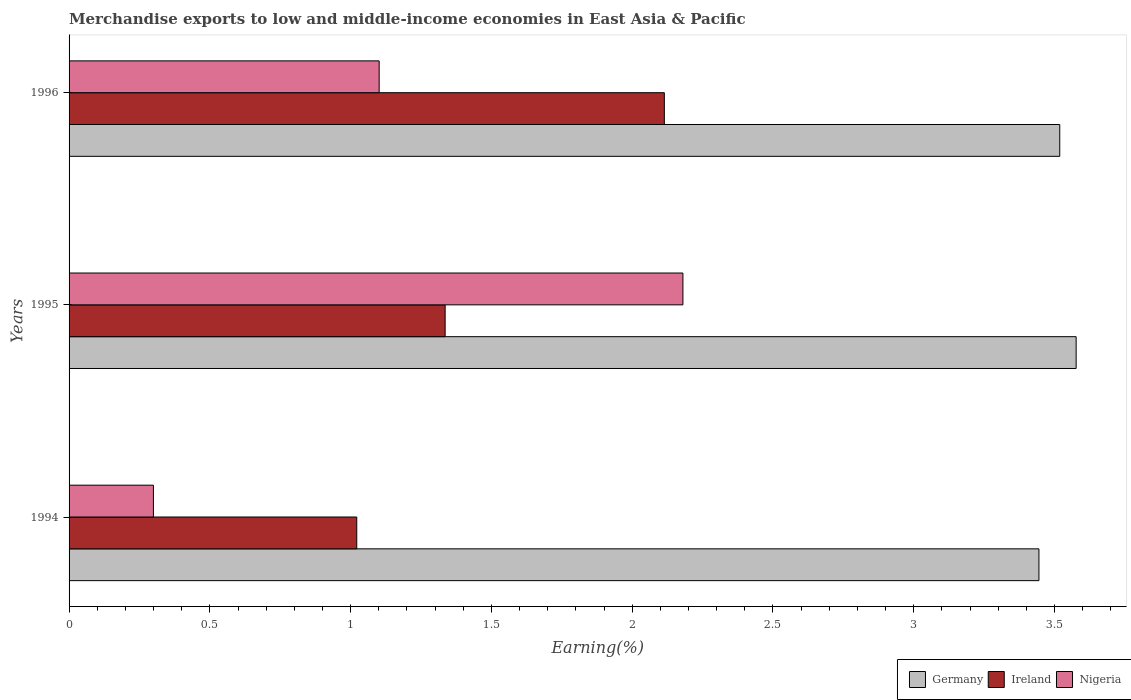Are the number of bars per tick equal to the number of legend labels?
Ensure brevity in your answer.  Yes. How many bars are there on the 1st tick from the top?
Offer a very short reply. 3. How many bars are there on the 3rd tick from the bottom?
Offer a very short reply. 3. What is the label of the 3rd group of bars from the top?
Provide a succinct answer. 1994. In how many cases, is the number of bars for a given year not equal to the number of legend labels?
Your response must be concise. 0. What is the percentage of amount earned from merchandise exports in Germany in 1996?
Your response must be concise. 3.52. Across all years, what is the maximum percentage of amount earned from merchandise exports in Nigeria?
Your answer should be compact. 2.18. Across all years, what is the minimum percentage of amount earned from merchandise exports in Ireland?
Your answer should be very brief. 1.02. What is the total percentage of amount earned from merchandise exports in Germany in the graph?
Make the answer very short. 10.54. What is the difference between the percentage of amount earned from merchandise exports in Nigeria in 1994 and that in 1995?
Provide a succinct answer. -1.88. What is the difference between the percentage of amount earned from merchandise exports in Ireland in 1994 and the percentage of amount earned from merchandise exports in Germany in 1995?
Provide a short and direct response. -2.56. What is the average percentage of amount earned from merchandise exports in Ireland per year?
Keep it short and to the point. 1.49. In the year 1994, what is the difference between the percentage of amount earned from merchandise exports in Germany and percentage of amount earned from merchandise exports in Nigeria?
Your response must be concise. 3.15. In how many years, is the percentage of amount earned from merchandise exports in Nigeria greater than 1.5 %?
Give a very brief answer. 1. What is the ratio of the percentage of amount earned from merchandise exports in Nigeria in 1995 to that in 1996?
Make the answer very short. 1.98. Is the percentage of amount earned from merchandise exports in Nigeria in 1994 less than that in 1996?
Offer a terse response. Yes. What is the difference between the highest and the second highest percentage of amount earned from merchandise exports in Nigeria?
Your answer should be compact. 1.08. What is the difference between the highest and the lowest percentage of amount earned from merchandise exports in Germany?
Your response must be concise. 0.13. In how many years, is the percentage of amount earned from merchandise exports in Ireland greater than the average percentage of amount earned from merchandise exports in Ireland taken over all years?
Your answer should be compact. 1. Is the sum of the percentage of amount earned from merchandise exports in Ireland in 1995 and 1996 greater than the maximum percentage of amount earned from merchandise exports in Germany across all years?
Provide a short and direct response. No. What does the 2nd bar from the top in 1994 represents?
Provide a succinct answer. Ireland. What does the 3rd bar from the bottom in 1995 represents?
Your answer should be compact. Nigeria. How many years are there in the graph?
Make the answer very short. 3. What is the difference between two consecutive major ticks on the X-axis?
Give a very brief answer. 0.5. Does the graph contain grids?
Your answer should be very brief. No. How many legend labels are there?
Keep it short and to the point. 3. What is the title of the graph?
Provide a short and direct response. Merchandise exports to low and middle-income economies in East Asia & Pacific. What is the label or title of the X-axis?
Give a very brief answer. Earning(%). What is the Earning(%) of Germany in 1994?
Offer a terse response. 3.44. What is the Earning(%) of Ireland in 1994?
Give a very brief answer. 1.02. What is the Earning(%) of Nigeria in 1994?
Ensure brevity in your answer.  0.3. What is the Earning(%) of Germany in 1995?
Provide a short and direct response. 3.58. What is the Earning(%) in Ireland in 1995?
Your response must be concise. 1.34. What is the Earning(%) of Nigeria in 1995?
Make the answer very short. 2.18. What is the Earning(%) in Germany in 1996?
Your answer should be very brief. 3.52. What is the Earning(%) of Ireland in 1996?
Ensure brevity in your answer.  2.11. What is the Earning(%) in Nigeria in 1996?
Your answer should be very brief. 1.1. Across all years, what is the maximum Earning(%) of Germany?
Ensure brevity in your answer.  3.58. Across all years, what is the maximum Earning(%) in Ireland?
Offer a very short reply. 2.11. Across all years, what is the maximum Earning(%) in Nigeria?
Your answer should be very brief. 2.18. Across all years, what is the minimum Earning(%) of Germany?
Make the answer very short. 3.44. Across all years, what is the minimum Earning(%) of Ireland?
Provide a succinct answer. 1.02. Across all years, what is the minimum Earning(%) of Nigeria?
Your answer should be compact. 0.3. What is the total Earning(%) in Germany in the graph?
Make the answer very short. 10.54. What is the total Earning(%) of Ireland in the graph?
Make the answer very short. 4.47. What is the total Earning(%) of Nigeria in the graph?
Ensure brevity in your answer.  3.58. What is the difference between the Earning(%) of Germany in 1994 and that in 1995?
Make the answer very short. -0.13. What is the difference between the Earning(%) of Ireland in 1994 and that in 1995?
Provide a succinct answer. -0.31. What is the difference between the Earning(%) of Nigeria in 1994 and that in 1995?
Your response must be concise. -1.88. What is the difference between the Earning(%) in Germany in 1994 and that in 1996?
Your response must be concise. -0.07. What is the difference between the Earning(%) in Ireland in 1994 and that in 1996?
Provide a succinct answer. -1.09. What is the difference between the Earning(%) in Nigeria in 1994 and that in 1996?
Ensure brevity in your answer.  -0.8. What is the difference between the Earning(%) in Germany in 1995 and that in 1996?
Your response must be concise. 0.06. What is the difference between the Earning(%) of Ireland in 1995 and that in 1996?
Provide a succinct answer. -0.78. What is the difference between the Earning(%) of Nigeria in 1995 and that in 1996?
Offer a very short reply. 1.08. What is the difference between the Earning(%) of Germany in 1994 and the Earning(%) of Ireland in 1995?
Offer a terse response. 2.11. What is the difference between the Earning(%) of Germany in 1994 and the Earning(%) of Nigeria in 1995?
Give a very brief answer. 1.26. What is the difference between the Earning(%) in Ireland in 1994 and the Earning(%) in Nigeria in 1995?
Provide a succinct answer. -1.16. What is the difference between the Earning(%) of Germany in 1994 and the Earning(%) of Ireland in 1996?
Offer a very short reply. 1.33. What is the difference between the Earning(%) of Germany in 1994 and the Earning(%) of Nigeria in 1996?
Provide a succinct answer. 2.34. What is the difference between the Earning(%) in Ireland in 1994 and the Earning(%) in Nigeria in 1996?
Offer a very short reply. -0.08. What is the difference between the Earning(%) in Germany in 1995 and the Earning(%) in Ireland in 1996?
Make the answer very short. 1.46. What is the difference between the Earning(%) of Germany in 1995 and the Earning(%) of Nigeria in 1996?
Offer a terse response. 2.48. What is the difference between the Earning(%) in Ireland in 1995 and the Earning(%) in Nigeria in 1996?
Give a very brief answer. 0.23. What is the average Earning(%) of Germany per year?
Offer a very short reply. 3.51. What is the average Earning(%) of Ireland per year?
Offer a terse response. 1.49. What is the average Earning(%) in Nigeria per year?
Make the answer very short. 1.19. In the year 1994, what is the difference between the Earning(%) of Germany and Earning(%) of Ireland?
Give a very brief answer. 2.42. In the year 1994, what is the difference between the Earning(%) of Germany and Earning(%) of Nigeria?
Ensure brevity in your answer.  3.15. In the year 1994, what is the difference between the Earning(%) of Ireland and Earning(%) of Nigeria?
Provide a short and direct response. 0.72. In the year 1995, what is the difference between the Earning(%) of Germany and Earning(%) of Ireland?
Offer a very short reply. 2.24. In the year 1995, what is the difference between the Earning(%) of Germany and Earning(%) of Nigeria?
Your answer should be very brief. 1.4. In the year 1995, what is the difference between the Earning(%) of Ireland and Earning(%) of Nigeria?
Provide a succinct answer. -0.84. In the year 1996, what is the difference between the Earning(%) in Germany and Earning(%) in Ireland?
Your answer should be very brief. 1.4. In the year 1996, what is the difference between the Earning(%) in Germany and Earning(%) in Nigeria?
Provide a short and direct response. 2.42. In the year 1996, what is the difference between the Earning(%) in Ireland and Earning(%) in Nigeria?
Keep it short and to the point. 1.01. What is the ratio of the Earning(%) of Germany in 1994 to that in 1995?
Your answer should be very brief. 0.96. What is the ratio of the Earning(%) in Ireland in 1994 to that in 1995?
Offer a very short reply. 0.77. What is the ratio of the Earning(%) of Nigeria in 1994 to that in 1995?
Give a very brief answer. 0.14. What is the ratio of the Earning(%) in Germany in 1994 to that in 1996?
Give a very brief answer. 0.98. What is the ratio of the Earning(%) in Ireland in 1994 to that in 1996?
Provide a succinct answer. 0.48. What is the ratio of the Earning(%) of Nigeria in 1994 to that in 1996?
Provide a succinct answer. 0.27. What is the ratio of the Earning(%) of Germany in 1995 to that in 1996?
Your answer should be compact. 1.02. What is the ratio of the Earning(%) of Ireland in 1995 to that in 1996?
Give a very brief answer. 0.63. What is the ratio of the Earning(%) in Nigeria in 1995 to that in 1996?
Provide a short and direct response. 1.98. What is the difference between the highest and the second highest Earning(%) in Germany?
Keep it short and to the point. 0.06. What is the difference between the highest and the second highest Earning(%) of Ireland?
Your answer should be compact. 0.78. What is the difference between the highest and the second highest Earning(%) in Nigeria?
Make the answer very short. 1.08. What is the difference between the highest and the lowest Earning(%) of Germany?
Your response must be concise. 0.13. What is the difference between the highest and the lowest Earning(%) in Ireland?
Ensure brevity in your answer.  1.09. What is the difference between the highest and the lowest Earning(%) of Nigeria?
Keep it short and to the point. 1.88. 